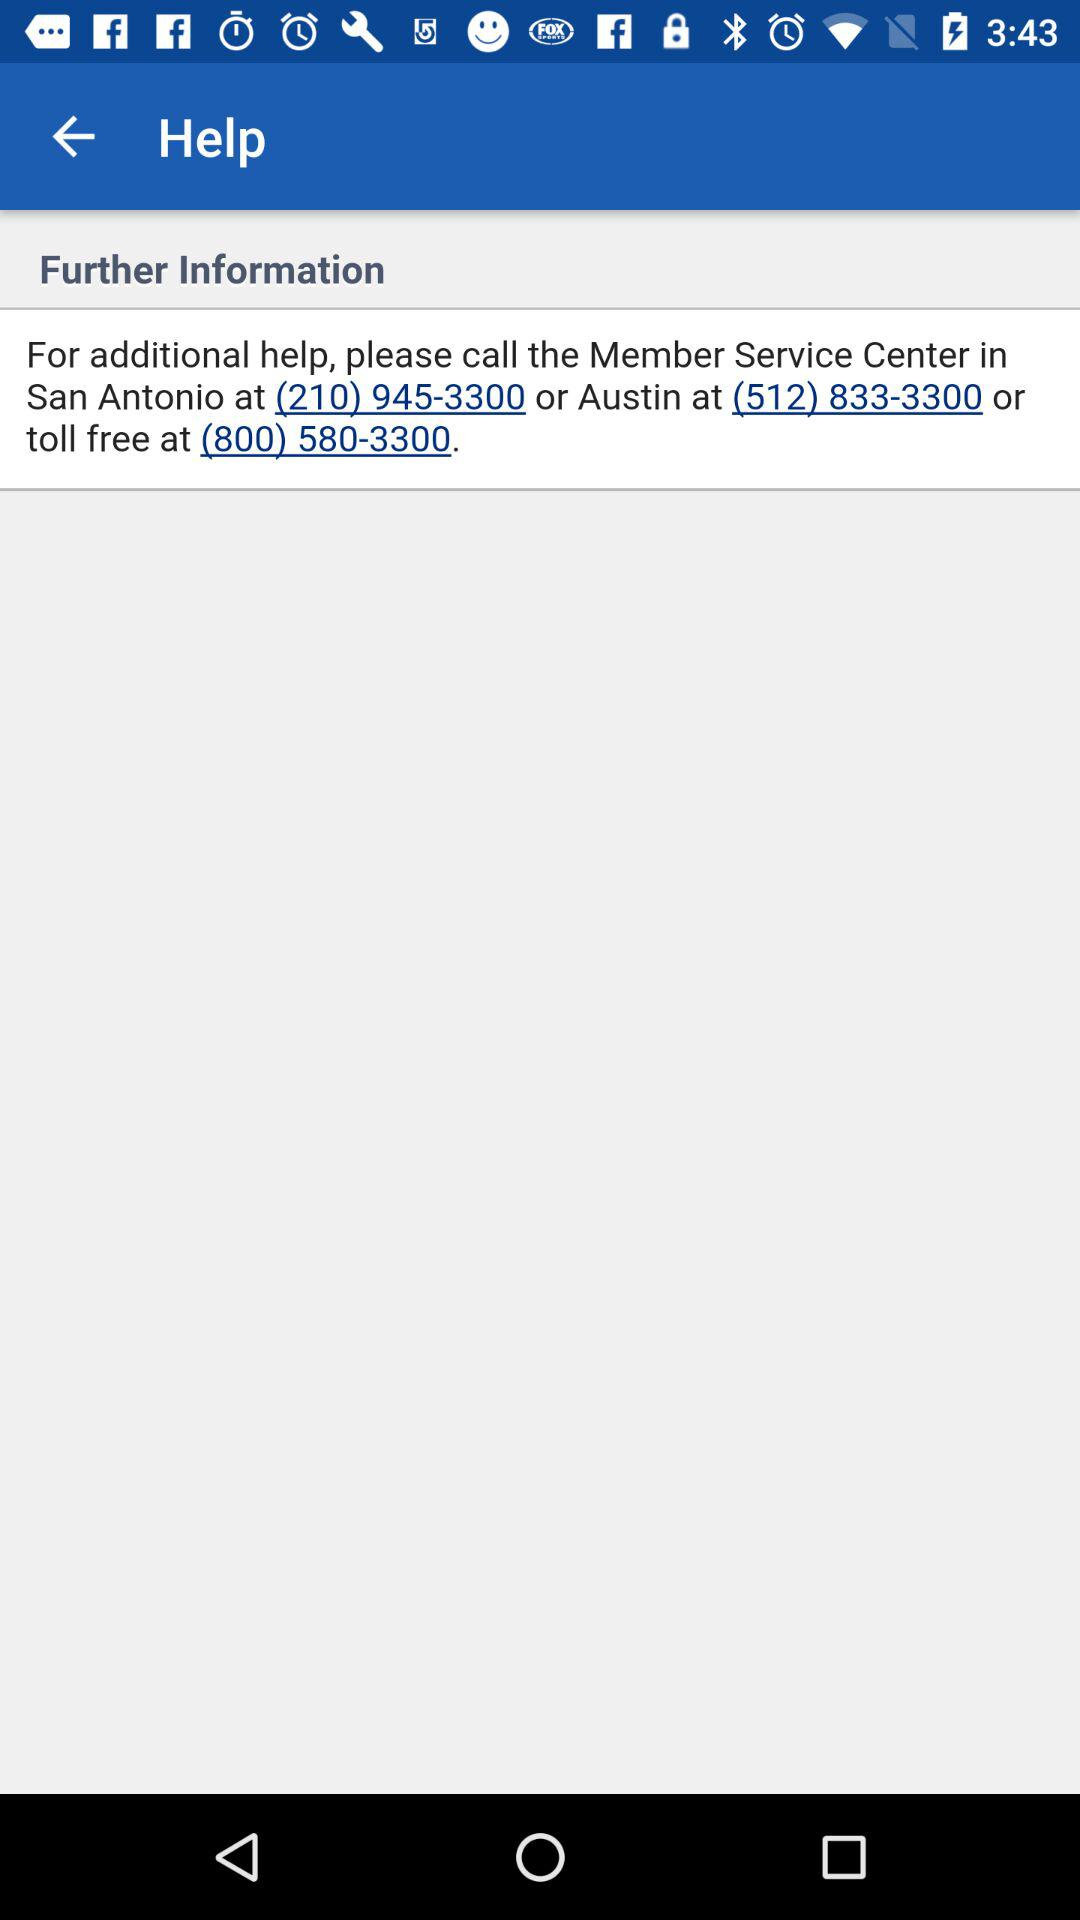What is the helpline number for the Member Service Center in Austin? The helpline number is (512) 833-3300. 